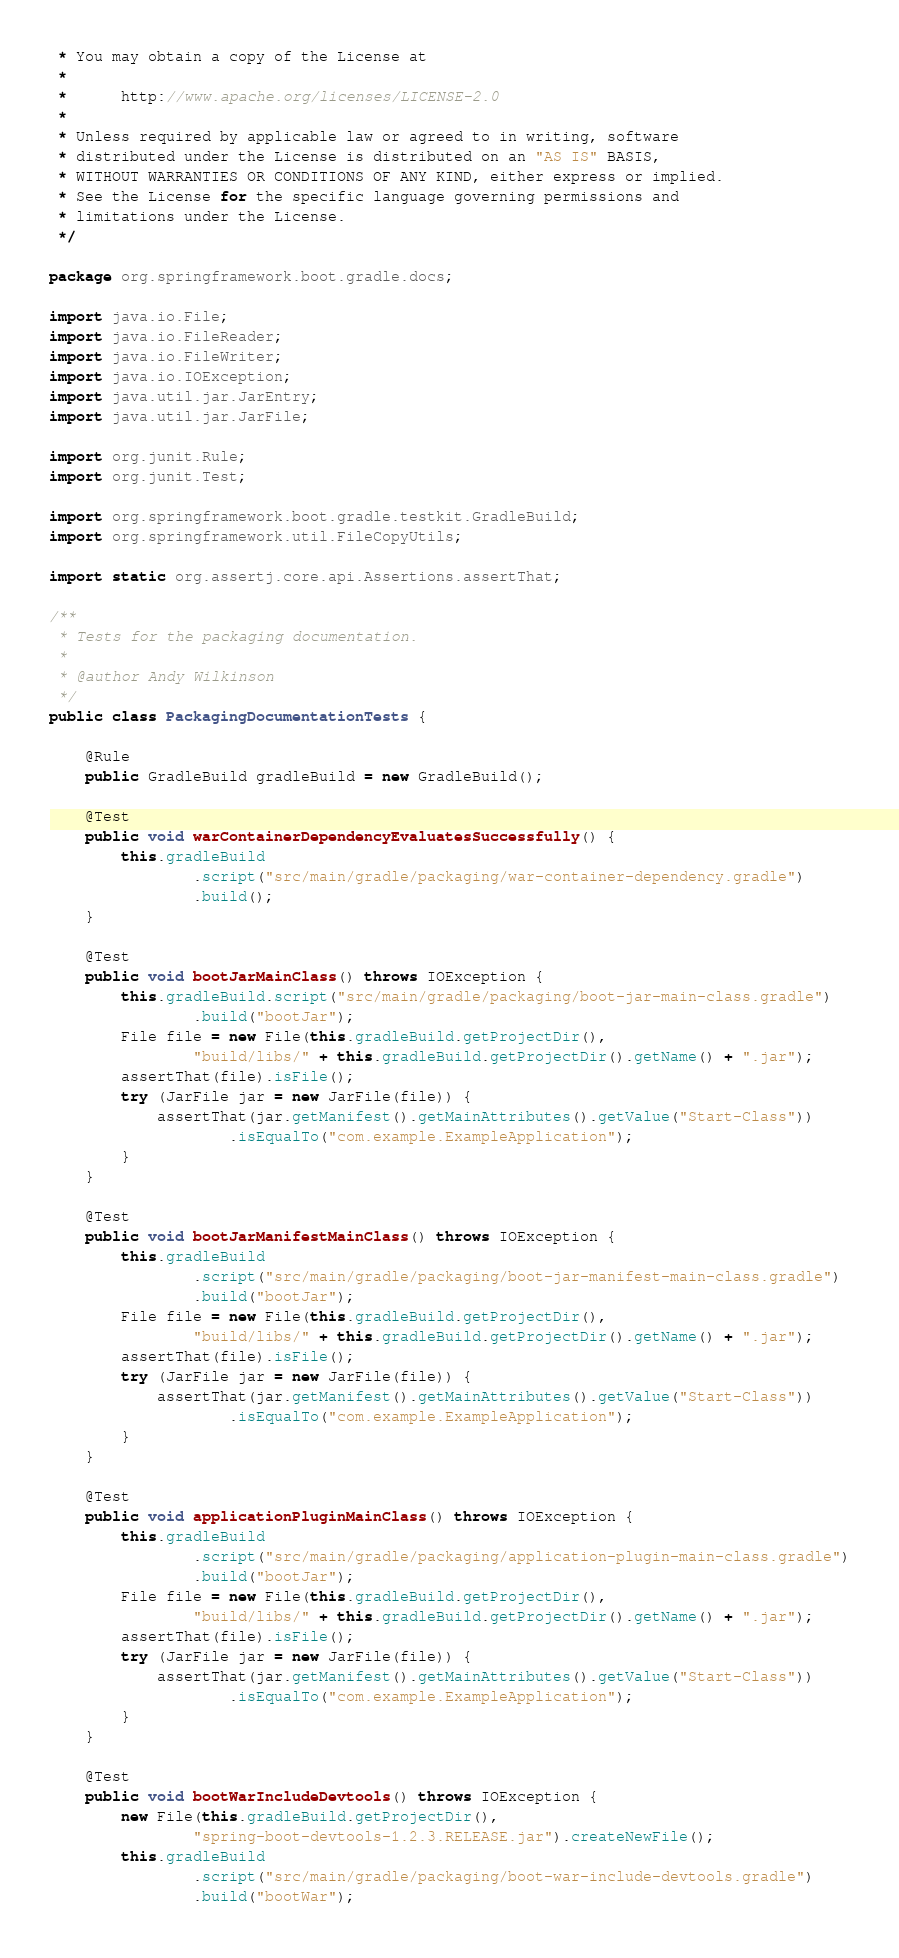Convert code to text. <code><loc_0><loc_0><loc_500><loc_500><_Java_> * You may obtain a copy of the License at
 *
 *      http://www.apache.org/licenses/LICENSE-2.0
 *
 * Unless required by applicable law or agreed to in writing, software
 * distributed under the License is distributed on an "AS IS" BASIS,
 * WITHOUT WARRANTIES OR CONDITIONS OF ANY KIND, either express or implied.
 * See the License for the specific language governing permissions and
 * limitations under the License.
 */

package org.springframework.boot.gradle.docs;

import java.io.File;
import java.io.FileReader;
import java.io.FileWriter;
import java.io.IOException;
import java.util.jar.JarEntry;
import java.util.jar.JarFile;

import org.junit.Rule;
import org.junit.Test;

import org.springframework.boot.gradle.testkit.GradleBuild;
import org.springframework.util.FileCopyUtils;

import static org.assertj.core.api.Assertions.assertThat;

/**
 * Tests for the packaging documentation.
 *
 * @author Andy Wilkinson
 */
public class PackagingDocumentationTests {

	@Rule
	public GradleBuild gradleBuild = new GradleBuild();

	@Test
	public void warContainerDependencyEvaluatesSuccessfully() {
		this.gradleBuild
				.script("src/main/gradle/packaging/war-container-dependency.gradle")
				.build();
	}

	@Test
	public void bootJarMainClass() throws IOException {
		this.gradleBuild.script("src/main/gradle/packaging/boot-jar-main-class.gradle")
				.build("bootJar");
		File file = new File(this.gradleBuild.getProjectDir(),
				"build/libs/" + this.gradleBuild.getProjectDir().getName() + ".jar");
		assertThat(file).isFile();
		try (JarFile jar = new JarFile(file)) {
			assertThat(jar.getManifest().getMainAttributes().getValue("Start-Class"))
					.isEqualTo("com.example.ExampleApplication");
		}
	}

	@Test
	public void bootJarManifestMainClass() throws IOException {
		this.gradleBuild
				.script("src/main/gradle/packaging/boot-jar-manifest-main-class.gradle")
				.build("bootJar");
		File file = new File(this.gradleBuild.getProjectDir(),
				"build/libs/" + this.gradleBuild.getProjectDir().getName() + ".jar");
		assertThat(file).isFile();
		try (JarFile jar = new JarFile(file)) {
			assertThat(jar.getManifest().getMainAttributes().getValue("Start-Class"))
					.isEqualTo("com.example.ExampleApplication");
		}
	}

	@Test
	public void applicationPluginMainClass() throws IOException {
		this.gradleBuild
				.script("src/main/gradle/packaging/application-plugin-main-class.gradle")
				.build("bootJar");
		File file = new File(this.gradleBuild.getProjectDir(),
				"build/libs/" + this.gradleBuild.getProjectDir().getName() + ".jar");
		assertThat(file).isFile();
		try (JarFile jar = new JarFile(file)) {
			assertThat(jar.getManifest().getMainAttributes().getValue("Start-Class"))
					.isEqualTo("com.example.ExampleApplication");
		}
	}

	@Test
	public void bootWarIncludeDevtools() throws IOException {
		new File(this.gradleBuild.getProjectDir(),
				"spring-boot-devtools-1.2.3.RELEASE.jar").createNewFile();
		this.gradleBuild
				.script("src/main/gradle/packaging/boot-war-include-devtools.gradle")
				.build("bootWar");</code> 